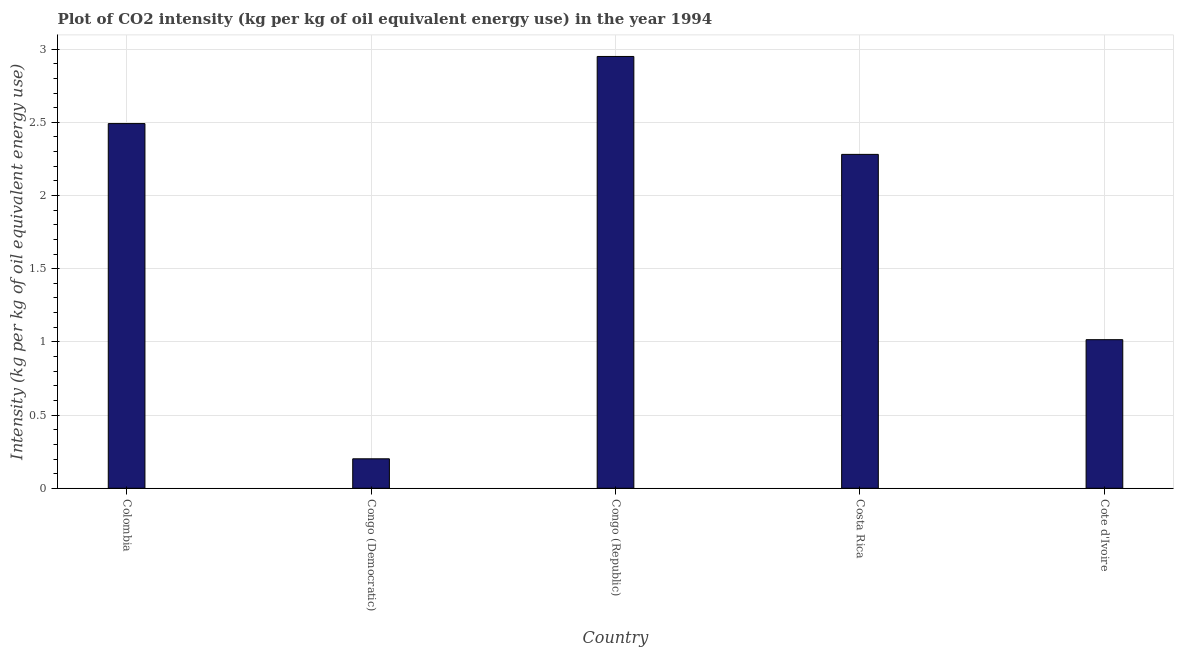What is the title of the graph?
Offer a very short reply. Plot of CO2 intensity (kg per kg of oil equivalent energy use) in the year 1994. What is the label or title of the X-axis?
Ensure brevity in your answer.  Country. What is the label or title of the Y-axis?
Make the answer very short. Intensity (kg per kg of oil equivalent energy use). What is the co2 intensity in Congo (Republic)?
Provide a short and direct response. 2.95. Across all countries, what is the maximum co2 intensity?
Your response must be concise. 2.95. Across all countries, what is the minimum co2 intensity?
Ensure brevity in your answer.  0.2. In which country was the co2 intensity maximum?
Ensure brevity in your answer.  Congo (Republic). In which country was the co2 intensity minimum?
Offer a very short reply. Congo (Democratic). What is the sum of the co2 intensity?
Your answer should be very brief. 8.94. What is the difference between the co2 intensity in Costa Rica and Cote d'Ivoire?
Give a very brief answer. 1.27. What is the average co2 intensity per country?
Provide a short and direct response. 1.79. What is the median co2 intensity?
Make the answer very short. 2.28. What is the ratio of the co2 intensity in Costa Rica to that in Cote d'Ivoire?
Keep it short and to the point. 2.25. Is the co2 intensity in Congo (Democratic) less than that in Cote d'Ivoire?
Give a very brief answer. Yes. What is the difference between the highest and the second highest co2 intensity?
Ensure brevity in your answer.  0.46. Is the sum of the co2 intensity in Congo (Democratic) and Costa Rica greater than the maximum co2 intensity across all countries?
Provide a short and direct response. No. What is the difference between the highest and the lowest co2 intensity?
Ensure brevity in your answer.  2.75. How many bars are there?
Your answer should be very brief. 5. Are the values on the major ticks of Y-axis written in scientific E-notation?
Your answer should be compact. No. What is the Intensity (kg per kg of oil equivalent energy use) of Colombia?
Your answer should be very brief. 2.49. What is the Intensity (kg per kg of oil equivalent energy use) in Congo (Democratic)?
Make the answer very short. 0.2. What is the Intensity (kg per kg of oil equivalent energy use) of Congo (Republic)?
Make the answer very short. 2.95. What is the Intensity (kg per kg of oil equivalent energy use) of Costa Rica?
Offer a terse response. 2.28. What is the Intensity (kg per kg of oil equivalent energy use) in Cote d'Ivoire?
Provide a succinct answer. 1.02. What is the difference between the Intensity (kg per kg of oil equivalent energy use) in Colombia and Congo (Democratic)?
Your answer should be compact. 2.29. What is the difference between the Intensity (kg per kg of oil equivalent energy use) in Colombia and Congo (Republic)?
Provide a short and direct response. -0.46. What is the difference between the Intensity (kg per kg of oil equivalent energy use) in Colombia and Costa Rica?
Your answer should be compact. 0.21. What is the difference between the Intensity (kg per kg of oil equivalent energy use) in Colombia and Cote d'Ivoire?
Provide a succinct answer. 1.48. What is the difference between the Intensity (kg per kg of oil equivalent energy use) in Congo (Democratic) and Congo (Republic)?
Your answer should be very brief. -2.75. What is the difference between the Intensity (kg per kg of oil equivalent energy use) in Congo (Democratic) and Costa Rica?
Provide a succinct answer. -2.08. What is the difference between the Intensity (kg per kg of oil equivalent energy use) in Congo (Democratic) and Cote d'Ivoire?
Offer a terse response. -0.81. What is the difference between the Intensity (kg per kg of oil equivalent energy use) in Congo (Republic) and Costa Rica?
Provide a succinct answer. 0.67. What is the difference between the Intensity (kg per kg of oil equivalent energy use) in Congo (Republic) and Cote d'Ivoire?
Your response must be concise. 1.93. What is the difference between the Intensity (kg per kg of oil equivalent energy use) in Costa Rica and Cote d'Ivoire?
Ensure brevity in your answer.  1.27. What is the ratio of the Intensity (kg per kg of oil equivalent energy use) in Colombia to that in Congo (Democratic)?
Your answer should be compact. 12.38. What is the ratio of the Intensity (kg per kg of oil equivalent energy use) in Colombia to that in Congo (Republic)?
Provide a succinct answer. 0.84. What is the ratio of the Intensity (kg per kg of oil equivalent energy use) in Colombia to that in Costa Rica?
Make the answer very short. 1.09. What is the ratio of the Intensity (kg per kg of oil equivalent energy use) in Colombia to that in Cote d'Ivoire?
Your response must be concise. 2.45. What is the ratio of the Intensity (kg per kg of oil equivalent energy use) in Congo (Democratic) to that in Congo (Republic)?
Your answer should be very brief. 0.07. What is the ratio of the Intensity (kg per kg of oil equivalent energy use) in Congo (Democratic) to that in Costa Rica?
Offer a very short reply. 0.09. What is the ratio of the Intensity (kg per kg of oil equivalent energy use) in Congo (Democratic) to that in Cote d'Ivoire?
Offer a very short reply. 0.2. What is the ratio of the Intensity (kg per kg of oil equivalent energy use) in Congo (Republic) to that in Costa Rica?
Ensure brevity in your answer.  1.29. What is the ratio of the Intensity (kg per kg of oil equivalent energy use) in Congo (Republic) to that in Cote d'Ivoire?
Your answer should be compact. 2.91. What is the ratio of the Intensity (kg per kg of oil equivalent energy use) in Costa Rica to that in Cote d'Ivoire?
Provide a succinct answer. 2.25. 